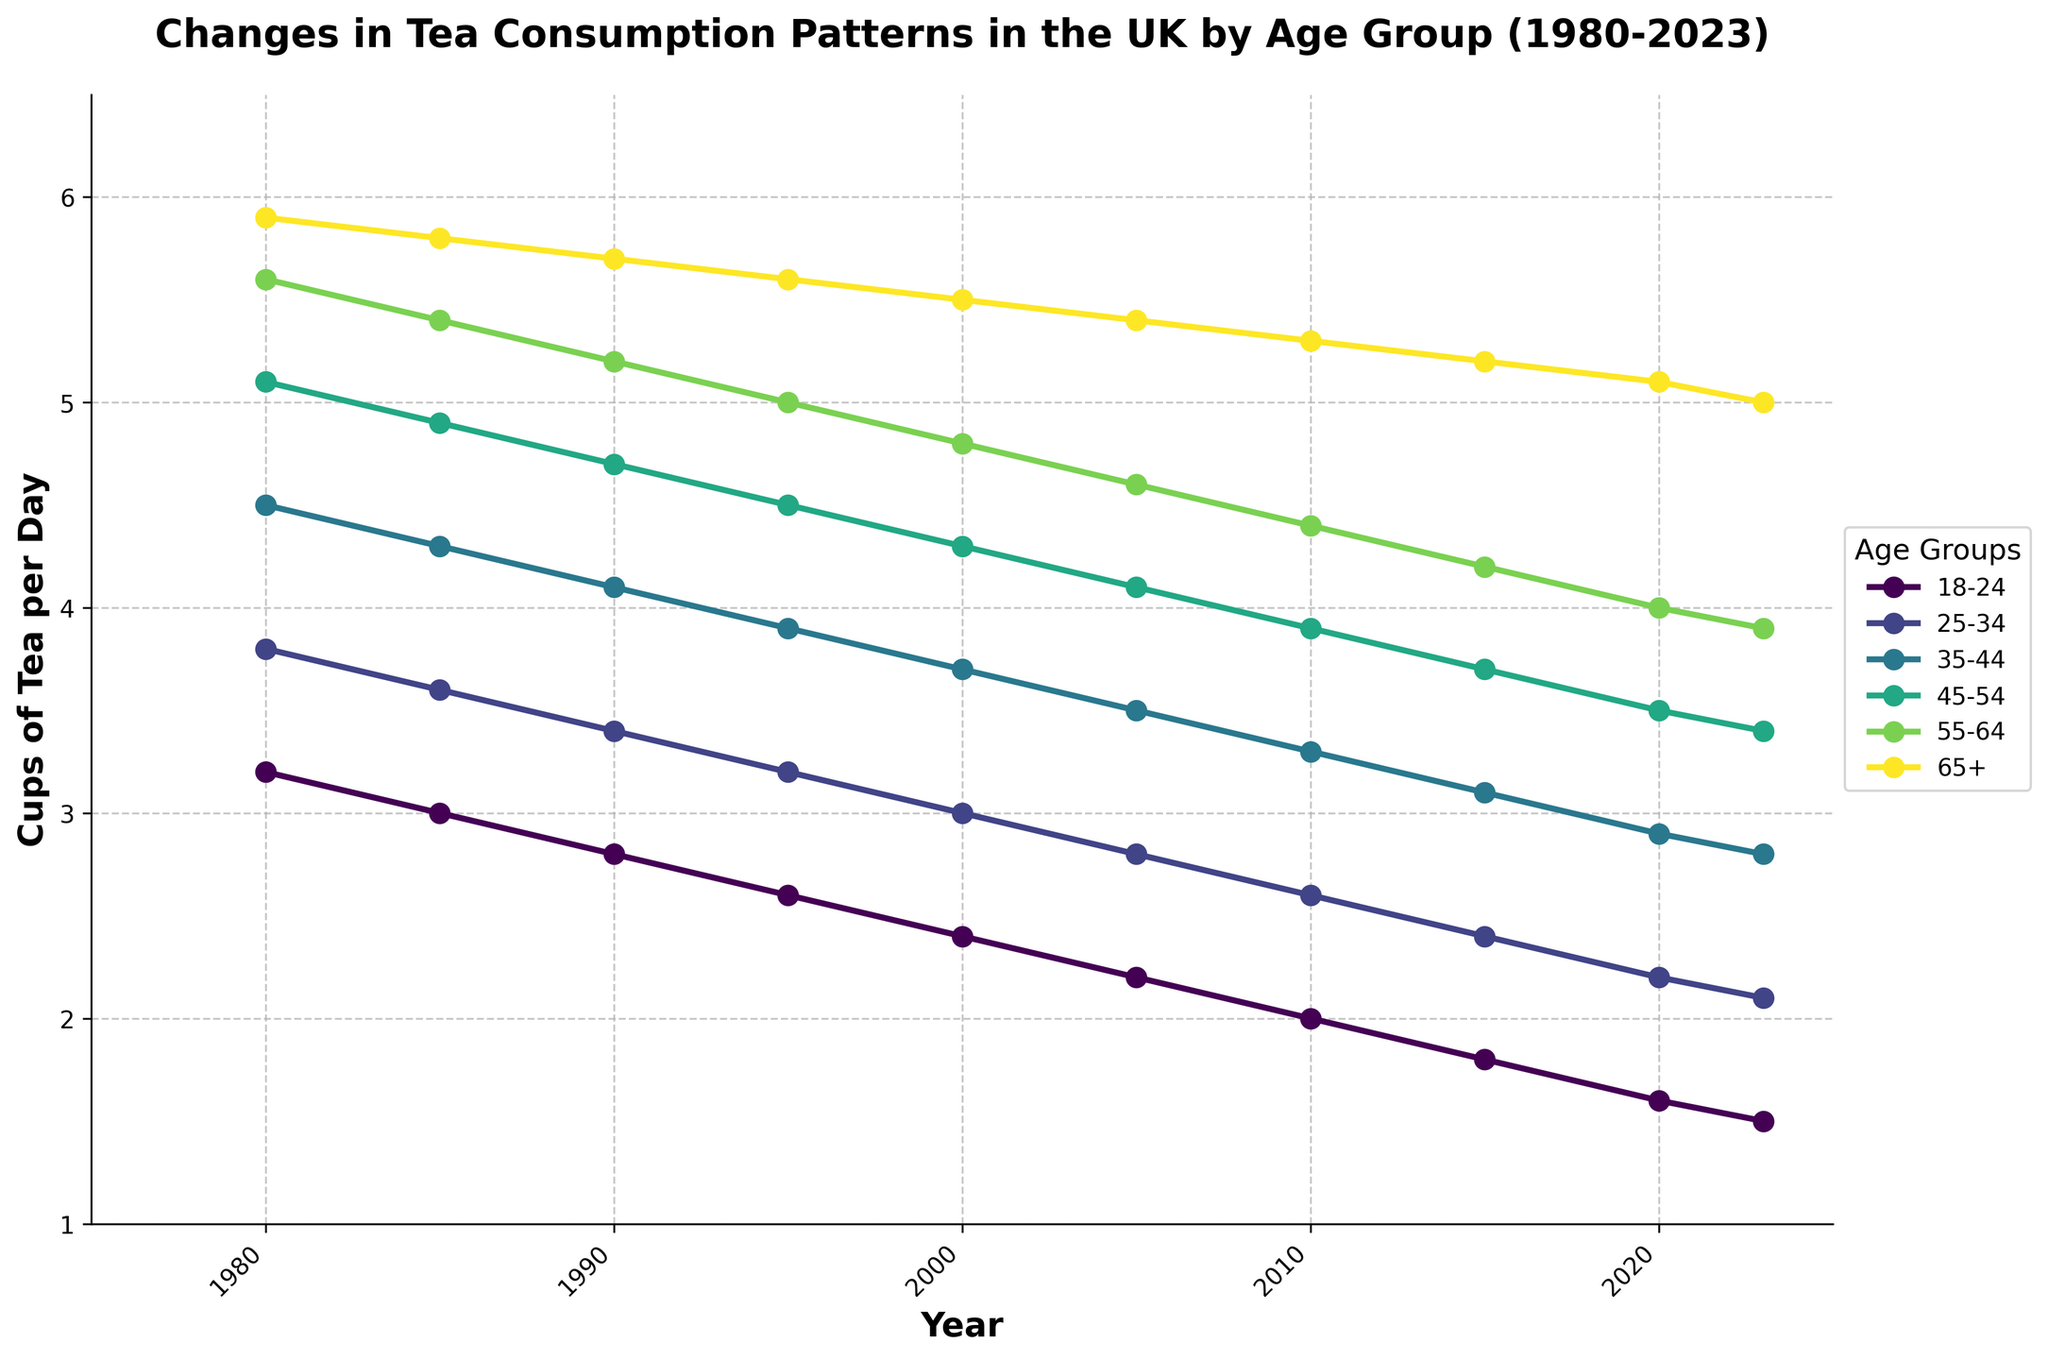What is the overall trend in tea consumption for the 18-24 age group from 1980 to 2023? The 18-24 age group shows a downward trend in tea consumption. By looking at the plot, the cups per day decrease from 3.2 in 1980 to 1.5 in 2023.
Answer: Downward trend Which age group had the highest tea consumption in 1980? By observing the plotted points for all age groups in 1980, the 65+ age group has the highest tea consumption rate at 5.9 cups of tea per day.
Answer: 65+ Between which years does the 45-54 age group tea consumption spiked the most? To find when the 45-54 age group had a spike, look for the largest positive changes in the values. There are no significant spikes, it's a steady decline from 5.1 in 1980 to 3.4 in 2023.
Answer: No significant spike, steady decline How much did the tea consumption for the 25-34 age group change from 1985 to 2023? The value in 1985 is 3.6 and the value in 2023 is 2.1. The change in tea consumption is 3.6 - 2.1 = 1.5 cups per day.
Answer: 1.5 cups per day Which age group shows the least change in tea consumption from 1980 to 2023? Observing the differences in values across years for all age groups, the 65+ age group changed from 5.9 in 1980 to 5.0 in 2023, which is a change of 0.9 cups per day. This is the least change compared to others.
Answer: 65+ In what year did the 35-44 age group first consume less than 4 cups of tea per day? Track the points for the 35-44 age group on the plot and identify when the value first falls below 4. This occurs in the year 1995 where the value is 3.9 cups per day.
Answer: 1995 In 2023, how does the tea consumption of the 55-64 age group compare to the 65+ age group? Comparing the two values in 2023, the 55-64 age group is at 3.9 cups per day and the 65+ age group is at 5.0 cups per day. Thus, 55-64 age group has a lower tea consumption.
Answer: Lower tea consumption Which age group had the steepest decline in tea consumption over the entire period? To identify the steepest decline, compute the difference between the values in 1980 and 2023 for each age group. The 18-24 age group's value dropped from 3.2 to 1.5, resulting in a difference of 1.7 which is the steepest.
Answer: 18-24 On average, how many cups of tea per day did the 65+ age group consume from 1980 to 2023? Add all the values for the 65+ age group and divide by the number of years. (5.9 + 5.8 + 5.7 + 5.6 + 5.5 + 5.4 + 5.3 + 5.2 + 5.1 + 5.0) / 10 = 5.45 cups per day on average.
Answer: 5.45 cups per day When did the 25-34 age group tea consumption fall below 3 cups per day? The graph shows that the 25-34 age group tea consumption fell below 3 cups per day after the year 2000, precisely in 2000, where the value is 3.0. The next point in 2005 shows 2.8 which confirms it.
Answer: 2005 